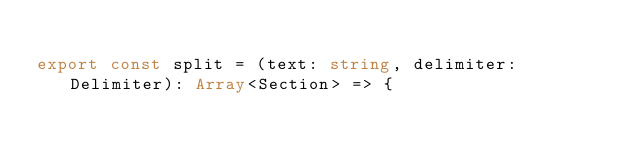Convert code to text. <code><loc_0><loc_0><loc_500><loc_500><_TypeScript_>
export const split = (text: string, delimiter: Delimiter): Array<Section> => {</code> 